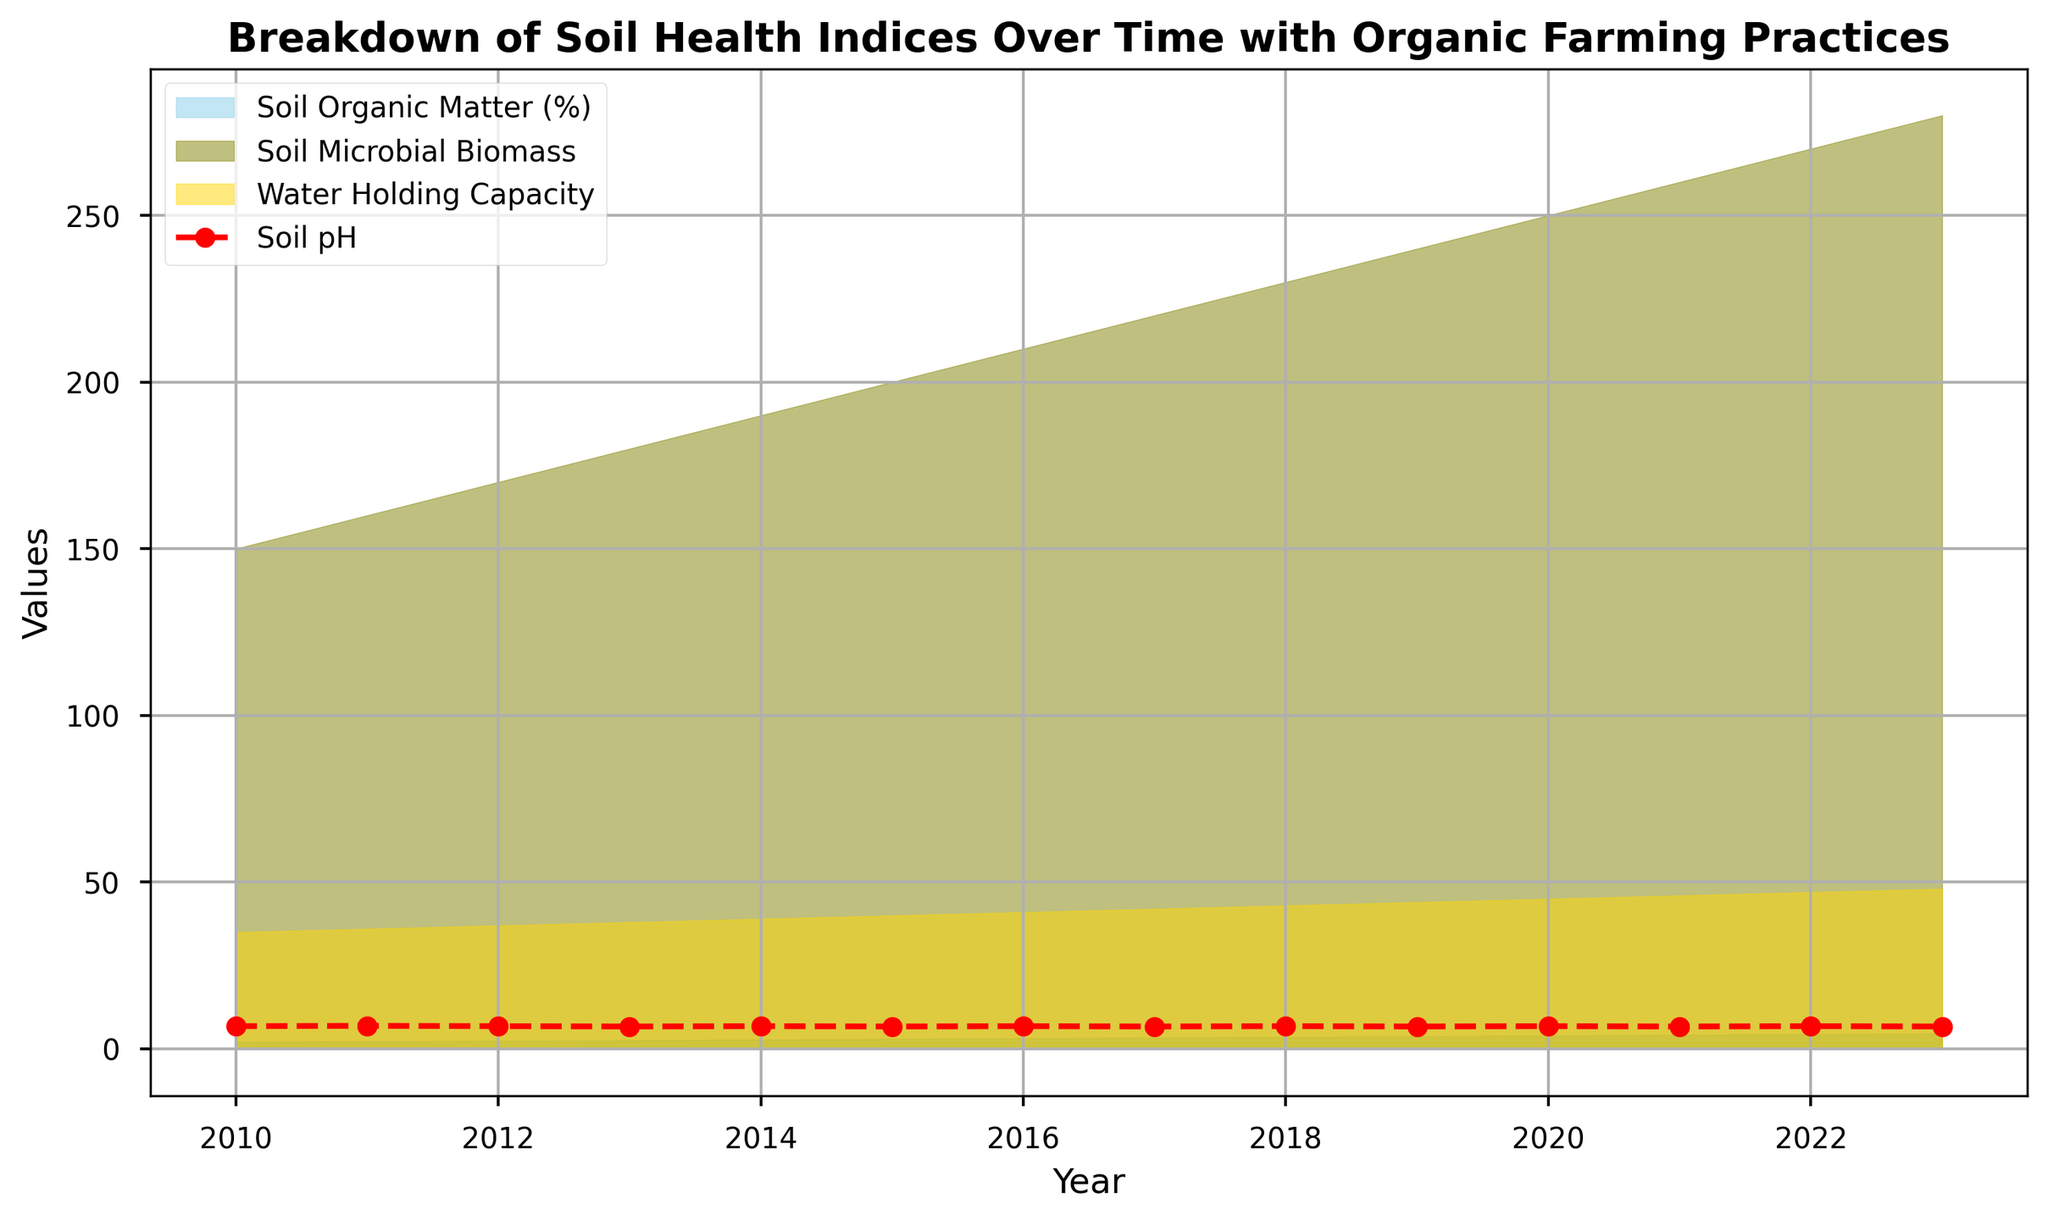What trend is observed in Soil Organic Matter Percentage from 2010 to 2023? From the figure, the Soil Organic Matter Percentage shows a consistent increasing trend over the years, starting from around 2.1% in 2010 and reaching approximately 4.6% by 2023.
Answer: Increasing trend Between which years did the Soil Microbial Biomass see the most substantial increase? Observing the figure, the Soil Microbial Biomass saw the steepest increase between approximately 2018 and 2019, during which it increased from about 230 units to 240 units.
Answer: 2018-2019 By how much did the Water Holding Capacity increase between 2010 and 2023? The Water Holding Capacity shows an increase from around 35 in 2010 to approximately 48 in 2023. The difference can be calculated as 48 - 35 = 13 units.
Answer: 13 units Does the Soil pH show any significant changes over the years, and if so, how? The Soil pH, represented by the red dashed line, fluctuates slightly between 6.7 and 6.8 throughout the years but does not show significant changes from 2010 to 2023.
Answer: No significant changes Which metric shows the most consistency in its values over time? By examining the figure, the Soil pH shows the most consistency over time with values remaining close to 6.7 and 6.8 throughout the years.
Answer: Soil pH What is the average value of Soil Microbial Biomass from 2010 to 2023? To find the average value, add up the Soil Microbial Biomass values for each year and divide by the number of years (14). The total value is 150 + 160 + 170 + 180 + 190 + 200 + 210 + 220 + 230 + 240 + 250 + 260 + 270 + 280 = 3310. Thus, the average is 3310 / 14 ≈ 236.43.
Answer: 236.43 Which two metrics visually overlap the most from 2015 to 2020? Looking at the filled areas in the figure, the Soil Microbial Biomass and Water Holding Capacity visually overlap the most from approximately 2015 to 2020.
Answer: Soil Microbial Biomass and Water Holding Capacity How much did the Soil Organic Matter Percentage increase between 2015 and 2020 compared to the increase between 2010 and 2015? From the chart, the Soil Organic Matter Percentage increased from 3.0 in 2015 to 4.0 in 2020, which is 4.0 - 3.0 = 1.0. From 2010 to 2015, it increased from 2.1 to 3.0, which is 3.0 - 2.1 = 0.9. Therefore, the increase between 2015 and 2020 is larger by 0.1.
Answer: 0.1 